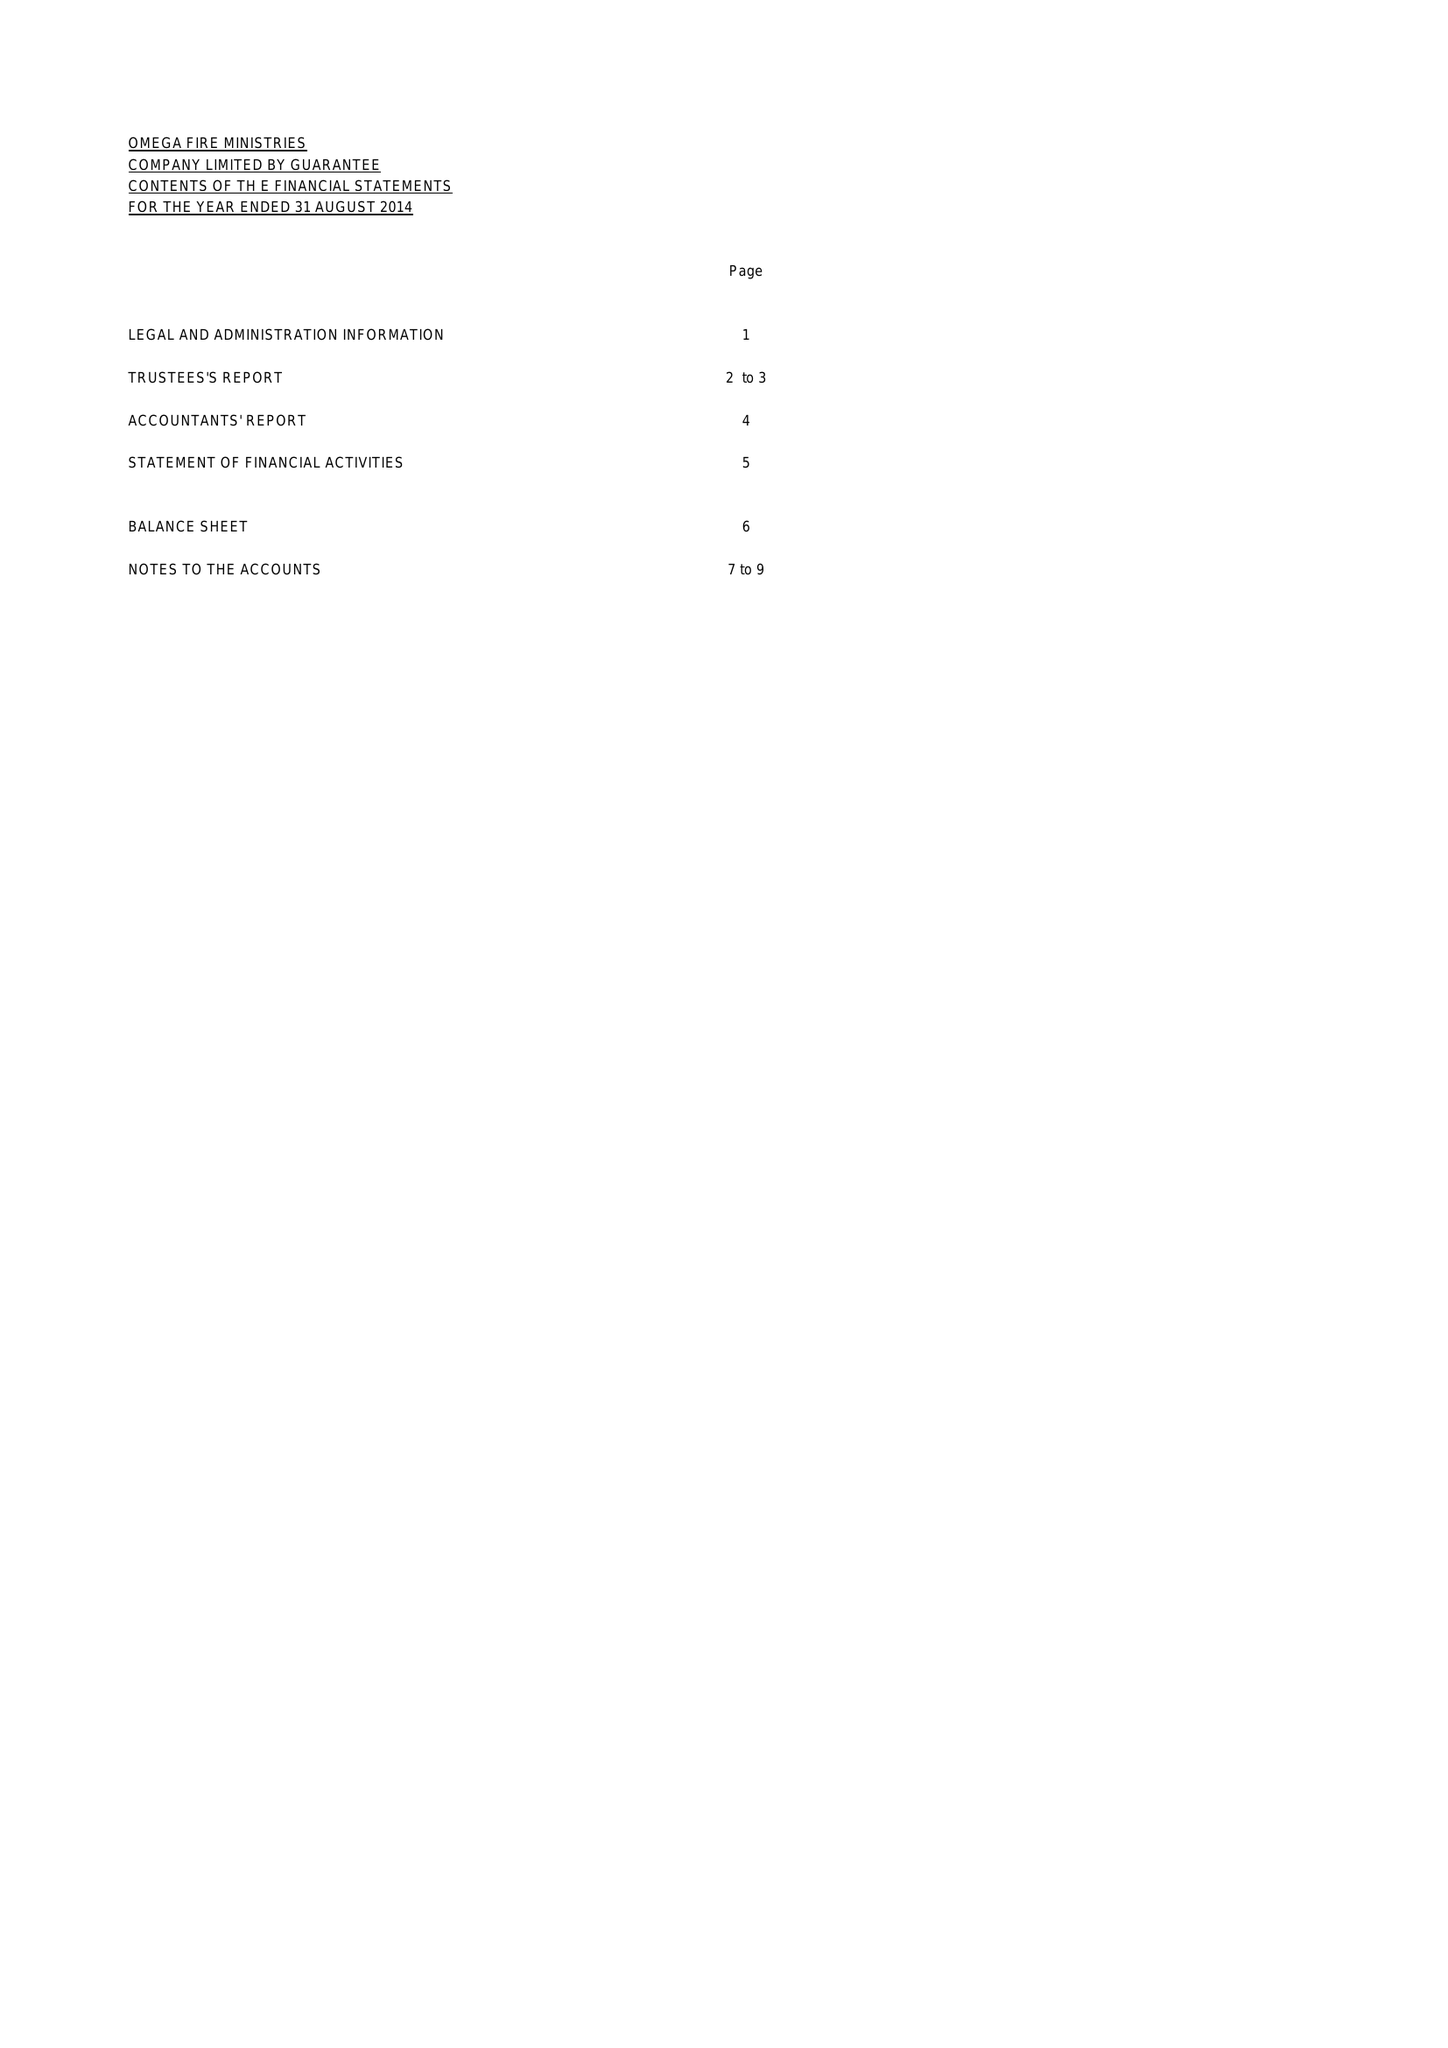What is the value for the address__post_town?
Answer the question using a single word or phrase. DAGENHAM 